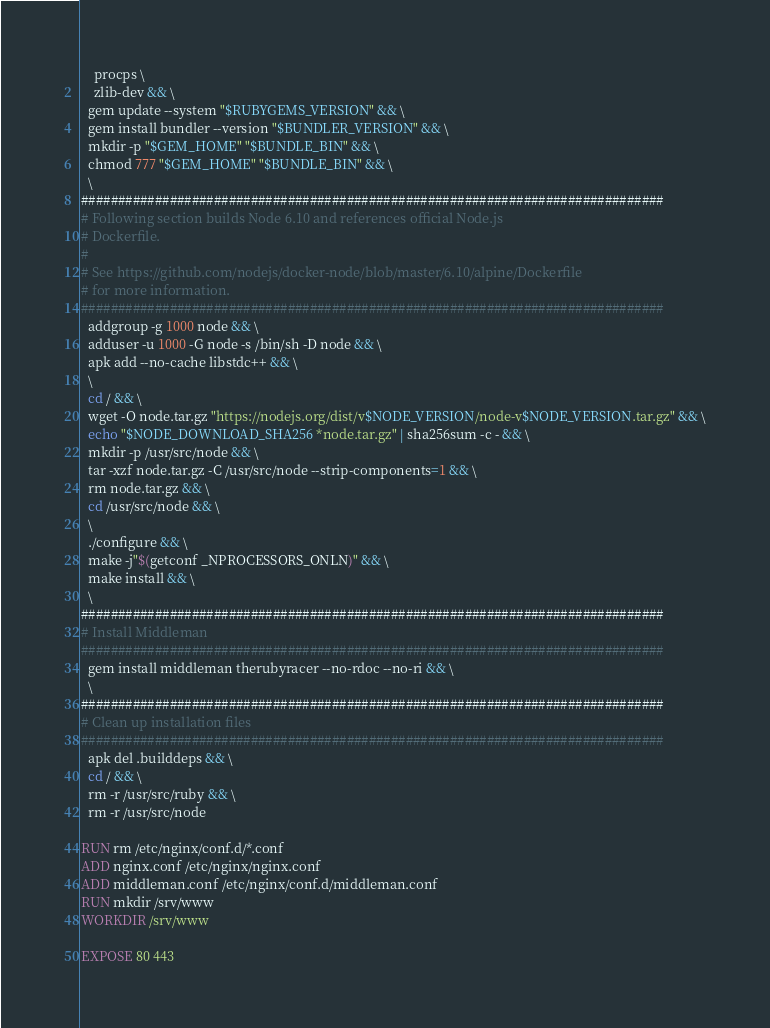<code> <loc_0><loc_0><loc_500><loc_500><_Dockerfile_>    procps \
    zlib-dev && \
  gem update --system "$RUBYGEMS_VERSION" && \
  gem install bundler --version "$BUNDLER_VERSION" && \
  mkdir -p "$GEM_HOME" "$BUNDLE_BIN" && \
  chmod 777 "$GEM_HOME" "$BUNDLE_BIN" && \
  \
###############################################################################
# Following section builds Node 6.10 and references official Node.js
# Dockerfile.
#
# See https://github.com/nodejs/docker-node/blob/master/6.10/alpine/Dockerfile
# for more information.
###############################################################################
  addgroup -g 1000 node && \
  adduser -u 1000 -G node -s /bin/sh -D node && \
  apk add --no-cache libstdc++ && \
  \
  cd / && \
  wget -O node.tar.gz "https://nodejs.org/dist/v$NODE_VERSION/node-v$NODE_VERSION.tar.gz" && \
  echo "$NODE_DOWNLOAD_SHA256 *node.tar.gz" | sha256sum -c - && \
  mkdir -p /usr/src/node && \
  tar -xzf node.tar.gz -C /usr/src/node --strip-components=1 && \
  rm node.tar.gz && \
  cd /usr/src/node && \
  \
  ./configure && \
  make -j"$(getconf _NPROCESSORS_ONLN)" && \
  make install && \
  \
###############################################################################
# Install Middleman
###############################################################################
  gem install middleman therubyracer --no-rdoc --no-ri && \
  \
###############################################################################
# Clean up installation files
###############################################################################
  apk del .builddeps && \
  cd / && \
  rm -r /usr/src/ruby && \
  rm -r /usr/src/node

RUN rm /etc/nginx/conf.d/*.conf
ADD nginx.conf /etc/nginx/nginx.conf
ADD middleman.conf /etc/nginx/conf.d/middleman.conf
RUN mkdir /srv/www
WORKDIR /srv/www

EXPOSE 80 443
</code> 